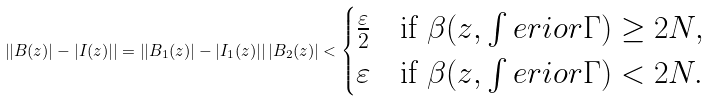<formula> <loc_0><loc_0><loc_500><loc_500>\left | | B ( z ) | - | I ( z ) | \right | = \left | | B _ { 1 } ( z ) | - | I _ { 1 } ( z ) | \right | | B _ { 2 } ( z ) | < \begin{cases} \frac { \varepsilon } { 2 } & \text {if } \beta ( z , \int e r i o r \Gamma ) \geq 2 N , \\ \varepsilon & \text {if } \beta ( z , \int e r i o r \Gamma ) < 2 N . \end{cases}</formula> 